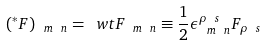<formula> <loc_0><loc_0><loc_500><loc_500>( ^ { * } F ) _ { \ m \ n } = \ w t { F } _ { \ m \ n } \equiv \frac { 1 } { 2 } \epsilon _ { \ m \ n } ^ { \rho \ s } F _ { \rho \ s }</formula> 